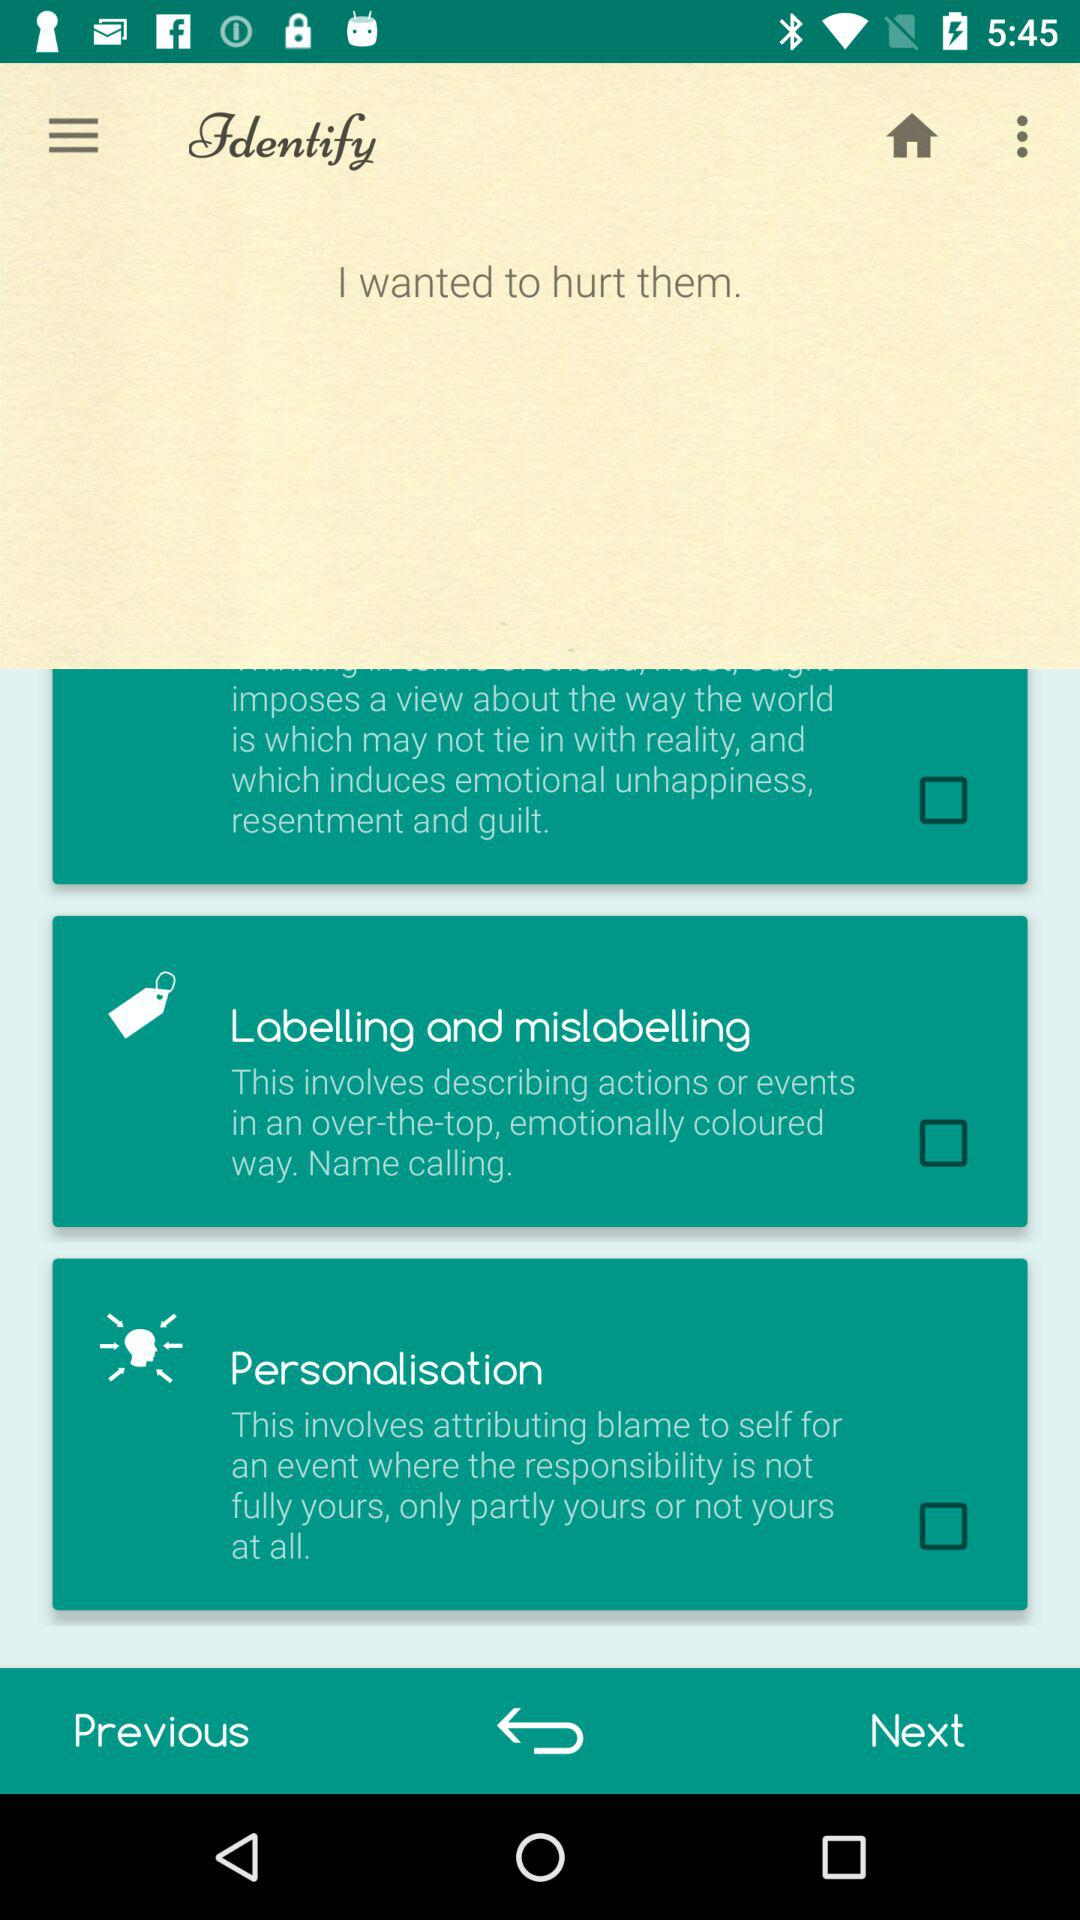What is the "Personalisation"? The "Personalisation" is "This involves attributing blame to self for an event where the responsibility is not fully yours, only partly yours or not yours at all". 